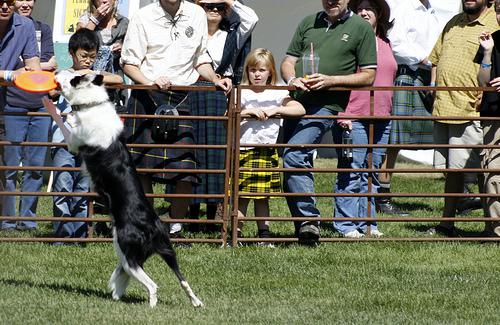Question: where are the people?
Choices:
A. Behind the fence.
B. On a field.
C. In the library.
D. In a classroom.
Answer with the letter. Answer: A Question: what color is most the frisbee?
Choices:
A. Pink.
B. Green.
C. Orange.
D. Red.
Answer with the letter. Answer: C Question: who is catching a frisbee?
Choices:
A. A woman.
B. A child.
C. A man.
D. A dog.
Answer with the letter. Answer: D 